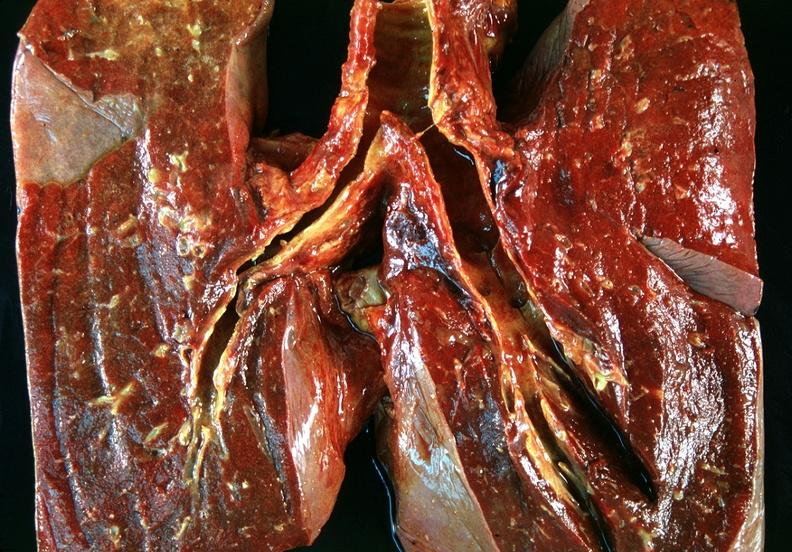how does this image show lung, bronchitis and oxygen toxicity?
Answer the question using a single word or phrase. With hyaline membranes 